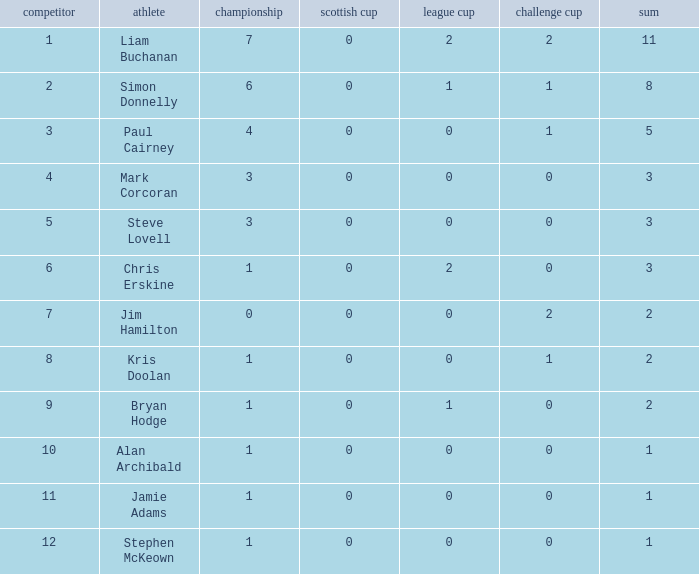What number does bryan hodge wear on his jersey? 1.0. 